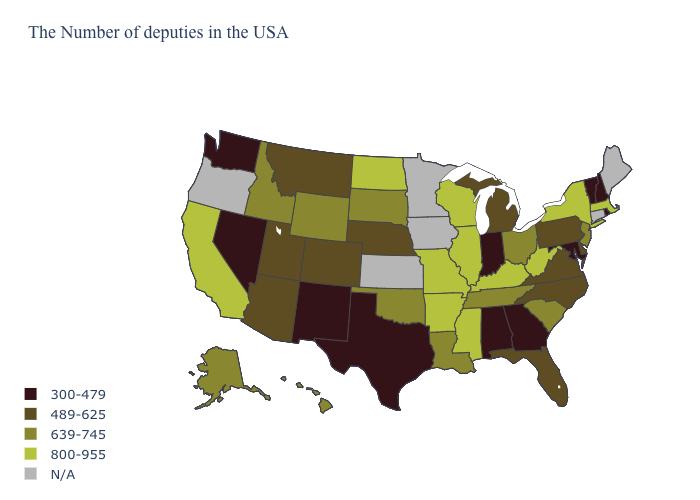Name the states that have a value in the range 639-745?
Short answer required. New Jersey, South Carolina, Ohio, Tennessee, Louisiana, Oklahoma, South Dakota, Wyoming, Idaho, Alaska, Hawaii. Name the states that have a value in the range N/A?
Write a very short answer. Maine, Connecticut, Minnesota, Iowa, Kansas, Oregon. What is the value of Colorado?
Give a very brief answer. 489-625. Does Michigan have the lowest value in the USA?
Keep it brief. No. Among the states that border Alabama , which have the lowest value?
Write a very short answer. Georgia. Name the states that have a value in the range 800-955?
Give a very brief answer. Massachusetts, New York, West Virginia, Kentucky, Wisconsin, Illinois, Mississippi, Missouri, Arkansas, North Dakota, California. Does Arizona have the highest value in the USA?
Be succinct. No. Does the first symbol in the legend represent the smallest category?
Give a very brief answer. Yes. What is the value of Kansas?
Answer briefly. N/A. Name the states that have a value in the range N/A?
Keep it brief. Maine, Connecticut, Minnesota, Iowa, Kansas, Oregon. Does the first symbol in the legend represent the smallest category?
Keep it brief. Yes. What is the highest value in the Northeast ?
Keep it brief. 800-955. What is the value of New Mexico?
Short answer required. 300-479. What is the highest value in the USA?
Be succinct. 800-955. How many symbols are there in the legend?
Short answer required. 5. 